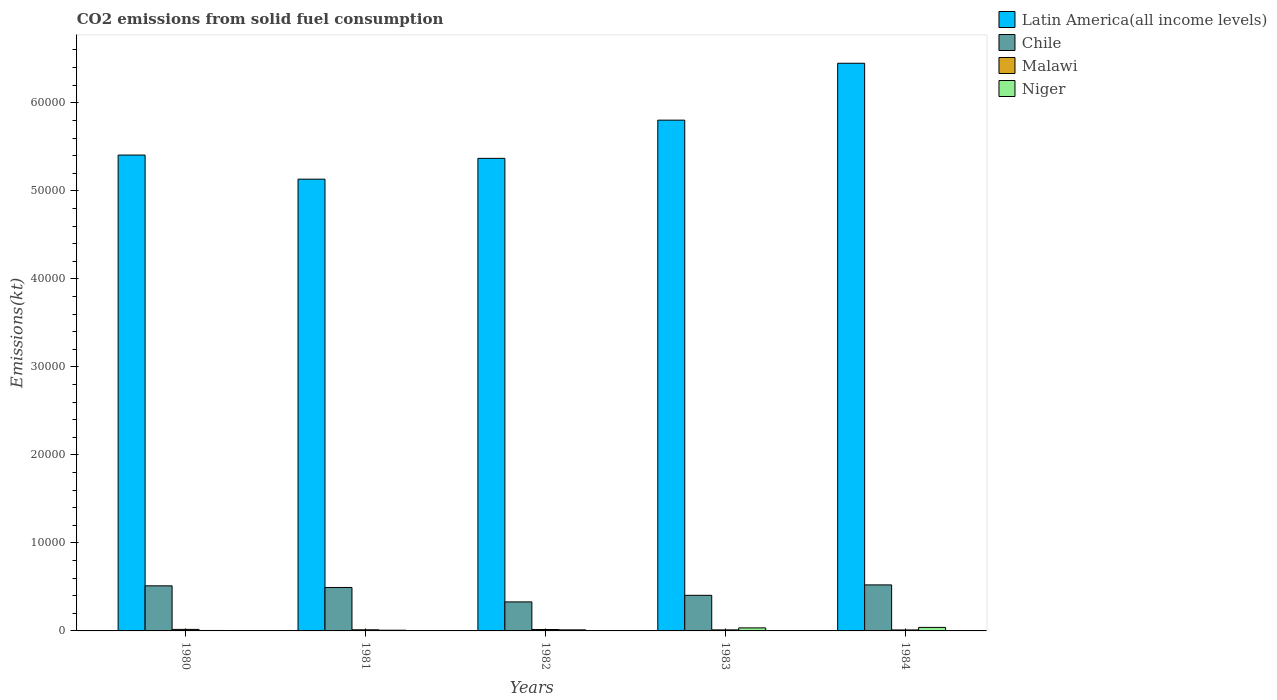Are the number of bars per tick equal to the number of legend labels?
Your answer should be very brief. Yes. Are the number of bars on each tick of the X-axis equal?
Keep it short and to the point. Yes. What is the amount of CO2 emitted in Malawi in 1983?
Your response must be concise. 117.34. Across all years, what is the maximum amount of CO2 emitted in Malawi?
Make the answer very short. 172.35. Across all years, what is the minimum amount of CO2 emitted in Latin America(all income levels)?
Make the answer very short. 5.13e+04. In which year was the amount of CO2 emitted in Malawi maximum?
Ensure brevity in your answer.  1980. In which year was the amount of CO2 emitted in Latin America(all income levels) minimum?
Your answer should be compact. 1981. What is the total amount of CO2 emitted in Latin America(all income levels) in the graph?
Your response must be concise. 2.82e+05. What is the difference between the amount of CO2 emitted in Niger in 1981 and that in 1983?
Your answer should be compact. -264.02. What is the difference between the amount of CO2 emitted in Malawi in 1980 and the amount of CO2 emitted in Latin America(all income levels) in 1984?
Ensure brevity in your answer.  -6.43e+04. What is the average amount of CO2 emitted in Malawi per year?
Keep it short and to the point. 137.88. In the year 1984, what is the difference between the amount of CO2 emitted in Latin America(all income levels) and amount of CO2 emitted in Niger?
Provide a short and direct response. 6.41e+04. What is the ratio of the amount of CO2 emitted in Chile in 1982 to that in 1983?
Keep it short and to the point. 0.82. Is the amount of CO2 emitted in Latin America(all income levels) in 1980 less than that in 1982?
Provide a succinct answer. No. Is the difference between the amount of CO2 emitted in Latin America(all income levels) in 1980 and 1983 greater than the difference between the amount of CO2 emitted in Niger in 1980 and 1983?
Offer a very short reply. No. What is the difference between the highest and the second highest amount of CO2 emitted in Latin America(all income levels)?
Make the answer very short. 6463.64. What is the difference between the highest and the lowest amount of CO2 emitted in Latin America(all income levels)?
Offer a very short reply. 1.32e+04. In how many years, is the amount of CO2 emitted in Malawi greater than the average amount of CO2 emitted in Malawi taken over all years?
Offer a very short reply. 2. What does the 4th bar from the left in 1982 represents?
Offer a terse response. Niger. What does the 2nd bar from the right in 1981 represents?
Offer a terse response. Malawi. Does the graph contain any zero values?
Give a very brief answer. No. Does the graph contain grids?
Provide a short and direct response. No. How many legend labels are there?
Your answer should be very brief. 4. What is the title of the graph?
Offer a very short reply. CO2 emissions from solid fuel consumption. What is the label or title of the Y-axis?
Your response must be concise. Emissions(kt). What is the Emissions(kt) of Latin America(all income levels) in 1980?
Provide a succinct answer. 5.41e+04. What is the Emissions(kt) in Chile in 1980?
Offer a terse response. 5122.8. What is the Emissions(kt) in Malawi in 1980?
Ensure brevity in your answer.  172.35. What is the Emissions(kt) of Niger in 1980?
Your answer should be compact. 51.34. What is the Emissions(kt) of Latin America(all income levels) in 1981?
Make the answer very short. 5.13e+04. What is the Emissions(kt) of Chile in 1981?
Offer a terse response. 4935.78. What is the Emissions(kt) in Malawi in 1981?
Give a very brief answer. 128.34. What is the Emissions(kt) in Niger in 1981?
Your answer should be very brief. 80.67. What is the Emissions(kt) in Latin America(all income levels) in 1982?
Offer a terse response. 5.37e+04. What is the Emissions(kt) in Chile in 1982?
Offer a very short reply. 3296.63. What is the Emissions(kt) in Malawi in 1982?
Provide a short and direct response. 161.35. What is the Emissions(kt) in Niger in 1982?
Make the answer very short. 121.01. What is the Emissions(kt) in Latin America(all income levels) in 1983?
Keep it short and to the point. 5.80e+04. What is the Emissions(kt) in Chile in 1983?
Your answer should be compact. 4044.7. What is the Emissions(kt) in Malawi in 1983?
Offer a terse response. 117.34. What is the Emissions(kt) in Niger in 1983?
Make the answer very short. 344.7. What is the Emissions(kt) in Latin America(all income levels) in 1984?
Ensure brevity in your answer.  6.45e+04. What is the Emissions(kt) in Chile in 1984?
Your answer should be very brief. 5229.14. What is the Emissions(kt) of Malawi in 1984?
Give a very brief answer. 110.01. What is the Emissions(kt) of Niger in 1984?
Provide a short and direct response. 399.7. Across all years, what is the maximum Emissions(kt) in Latin America(all income levels)?
Your answer should be compact. 6.45e+04. Across all years, what is the maximum Emissions(kt) in Chile?
Your answer should be very brief. 5229.14. Across all years, what is the maximum Emissions(kt) in Malawi?
Your answer should be very brief. 172.35. Across all years, what is the maximum Emissions(kt) of Niger?
Give a very brief answer. 399.7. Across all years, what is the minimum Emissions(kt) in Latin America(all income levels)?
Provide a short and direct response. 5.13e+04. Across all years, what is the minimum Emissions(kt) in Chile?
Offer a terse response. 3296.63. Across all years, what is the minimum Emissions(kt) of Malawi?
Offer a very short reply. 110.01. Across all years, what is the minimum Emissions(kt) in Niger?
Ensure brevity in your answer.  51.34. What is the total Emissions(kt) of Latin America(all income levels) in the graph?
Provide a short and direct response. 2.82e+05. What is the total Emissions(kt) in Chile in the graph?
Provide a short and direct response. 2.26e+04. What is the total Emissions(kt) in Malawi in the graph?
Offer a terse response. 689.4. What is the total Emissions(kt) of Niger in the graph?
Provide a succinct answer. 997.42. What is the difference between the Emissions(kt) of Latin America(all income levels) in 1980 and that in 1981?
Offer a very short reply. 2740.02. What is the difference between the Emissions(kt) in Chile in 1980 and that in 1981?
Keep it short and to the point. 187.02. What is the difference between the Emissions(kt) in Malawi in 1980 and that in 1981?
Provide a short and direct response. 44. What is the difference between the Emissions(kt) of Niger in 1980 and that in 1981?
Your response must be concise. -29.34. What is the difference between the Emissions(kt) in Latin America(all income levels) in 1980 and that in 1982?
Your answer should be very brief. 375.46. What is the difference between the Emissions(kt) in Chile in 1980 and that in 1982?
Ensure brevity in your answer.  1826.17. What is the difference between the Emissions(kt) of Malawi in 1980 and that in 1982?
Give a very brief answer. 11. What is the difference between the Emissions(kt) of Niger in 1980 and that in 1982?
Provide a succinct answer. -69.67. What is the difference between the Emissions(kt) of Latin America(all income levels) in 1980 and that in 1983?
Give a very brief answer. -3964.62. What is the difference between the Emissions(kt) in Chile in 1980 and that in 1983?
Keep it short and to the point. 1078.1. What is the difference between the Emissions(kt) of Malawi in 1980 and that in 1983?
Provide a short and direct response. 55.01. What is the difference between the Emissions(kt) of Niger in 1980 and that in 1983?
Your answer should be very brief. -293.36. What is the difference between the Emissions(kt) in Latin America(all income levels) in 1980 and that in 1984?
Keep it short and to the point. -1.04e+04. What is the difference between the Emissions(kt) in Chile in 1980 and that in 1984?
Keep it short and to the point. -106.34. What is the difference between the Emissions(kt) of Malawi in 1980 and that in 1984?
Your answer should be very brief. 62.34. What is the difference between the Emissions(kt) in Niger in 1980 and that in 1984?
Make the answer very short. -348.37. What is the difference between the Emissions(kt) in Latin America(all income levels) in 1981 and that in 1982?
Your answer should be very brief. -2364.56. What is the difference between the Emissions(kt) of Chile in 1981 and that in 1982?
Offer a terse response. 1639.15. What is the difference between the Emissions(kt) of Malawi in 1981 and that in 1982?
Ensure brevity in your answer.  -33. What is the difference between the Emissions(kt) in Niger in 1981 and that in 1982?
Your answer should be compact. -40.34. What is the difference between the Emissions(kt) in Latin America(all income levels) in 1981 and that in 1983?
Keep it short and to the point. -6704.64. What is the difference between the Emissions(kt) in Chile in 1981 and that in 1983?
Offer a terse response. 891.08. What is the difference between the Emissions(kt) of Malawi in 1981 and that in 1983?
Make the answer very short. 11. What is the difference between the Emissions(kt) of Niger in 1981 and that in 1983?
Your response must be concise. -264.02. What is the difference between the Emissions(kt) in Latin America(all income levels) in 1981 and that in 1984?
Provide a short and direct response. -1.32e+04. What is the difference between the Emissions(kt) in Chile in 1981 and that in 1984?
Provide a short and direct response. -293.36. What is the difference between the Emissions(kt) of Malawi in 1981 and that in 1984?
Provide a succinct answer. 18.34. What is the difference between the Emissions(kt) of Niger in 1981 and that in 1984?
Offer a terse response. -319.03. What is the difference between the Emissions(kt) of Latin America(all income levels) in 1982 and that in 1983?
Your answer should be compact. -4340.08. What is the difference between the Emissions(kt) of Chile in 1982 and that in 1983?
Provide a succinct answer. -748.07. What is the difference between the Emissions(kt) in Malawi in 1982 and that in 1983?
Give a very brief answer. 44. What is the difference between the Emissions(kt) in Niger in 1982 and that in 1983?
Your answer should be very brief. -223.69. What is the difference between the Emissions(kt) in Latin America(all income levels) in 1982 and that in 1984?
Provide a short and direct response. -1.08e+04. What is the difference between the Emissions(kt) in Chile in 1982 and that in 1984?
Keep it short and to the point. -1932.51. What is the difference between the Emissions(kt) in Malawi in 1982 and that in 1984?
Give a very brief answer. 51.34. What is the difference between the Emissions(kt) in Niger in 1982 and that in 1984?
Offer a very short reply. -278.69. What is the difference between the Emissions(kt) of Latin America(all income levels) in 1983 and that in 1984?
Provide a succinct answer. -6463.64. What is the difference between the Emissions(kt) of Chile in 1983 and that in 1984?
Offer a terse response. -1184.44. What is the difference between the Emissions(kt) in Malawi in 1983 and that in 1984?
Keep it short and to the point. 7.33. What is the difference between the Emissions(kt) of Niger in 1983 and that in 1984?
Offer a very short reply. -55.01. What is the difference between the Emissions(kt) in Latin America(all income levels) in 1980 and the Emissions(kt) in Chile in 1981?
Your answer should be very brief. 4.91e+04. What is the difference between the Emissions(kt) of Latin America(all income levels) in 1980 and the Emissions(kt) of Malawi in 1981?
Offer a very short reply. 5.39e+04. What is the difference between the Emissions(kt) in Latin America(all income levels) in 1980 and the Emissions(kt) in Niger in 1981?
Your response must be concise. 5.40e+04. What is the difference between the Emissions(kt) of Chile in 1980 and the Emissions(kt) of Malawi in 1981?
Your response must be concise. 4994.45. What is the difference between the Emissions(kt) in Chile in 1980 and the Emissions(kt) in Niger in 1981?
Keep it short and to the point. 5042.12. What is the difference between the Emissions(kt) of Malawi in 1980 and the Emissions(kt) of Niger in 1981?
Give a very brief answer. 91.67. What is the difference between the Emissions(kt) of Latin America(all income levels) in 1980 and the Emissions(kt) of Chile in 1982?
Your answer should be compact. 5.08e+04. What is the difference between the Emissions(kt) in Latin America(all income levels) in 1980 and the Emissions(kt) in Malawi in 1982?
Ensure brevity in your answer.  5.39e+04. What is the difference between the Emissions(kt) in Latin America(all income levels) in 1980 and the Emissions(kt) in Niger in 1982?
Keep it short and to the point. 5.39e+04. What is the difference between the Emissions(kt) in Chile in 1980 and the Emissions(kt) in Malawi in 1982?
Keep it short and to the point. 4961.45. What is the difference between the Emissions(kt) of Chile in 1980 and the Emissions(kt) of Niger in 1982?
Provide a short and direct response. 5001.79. What is the difference between the Emissions(kt) of Malawi in 1980 and the Emissions(kt) of Niger in 1982?
Your response must be concise. 51.34. What is the difference between the Emissions(kt) in Latin America(all income levels) in 1980 and the Emissions(kt) in Chile in 1983?
Provide a succinct answer. 5.00e+04. What is the difference between the Emissions(kt) in Latin America(all income levels) in 1980 and the Emissions(kt) in Malawi in 1983?
Your answer should be compact. 5.39e+04. What is the difference between the Emissions(kt) of Latin America(all income levels) in 1980 and the Emissions(kt) of Niger in 1983?
Your answer should be compact. 5.37e+04. What is the difference between the Emissions(kt) in Chile in 1980 and the Emissions(kt) in Malawi in 1983?
Your answer should be compact. 5005.45. What is the difference between the Emissions(kt) in Chile in 1980 and the Emissions(kt) in Niger in 1983?
Your answer should be compact. 4778.1. What is the difference between the Emissions(kt) in Malawi in 1980 and the Emissions(kt) in Niger in 1983?
Ensure brevity in your answer.  -172.35. What is the difference between the Emissions(kt) in Latin America(all income levels) in 1980 and the Emissions(kt) in Chile in 1984?
Offer a very short reply. 4.88e+04. What is the difference between the Emissions(kt) in Latin America(all income levels) in 1980 and the Emissions(kt) in Malawi in 1984?
Provide a short and direct response. 5.40e+04. What is the difference between the Emissions(kt) in Latin America(all income levels) in 1980 and the Emissions(kt) in Niger in 1984?
Your answer should be very brief. 5.37e+04. What is the difference between the Emissions(kt) of Chile in 1980 and the Emissions(kt) of Malawi in 1984?
Make the answer very short. 5012.79. What is the difference between the Emissions(kt) in Chile in 1980 and the Emissions(kt) in Niger in 1984?
Provide a short and direct response. 4723.1. What is the difference between the Emissions(kt) of Malawi in 1980 and the Emissions(kt) of Niger in 1984?
Offer a very short reply. -227.35. What is the difference between the Emissions(kt) in Latin America(all income levels) in 1981 and the Emissions(kt) in Chile in 1982?
Keep it short and to the point. 4.80e+04. What is the difference between the Emissions(kt) of Latin America(all income levels) in 1981 and the Emissions(kt) of Malawi in 1982?
Your answer should be very brief. 5.12e+04. What is the difference between the Emissions(kt) in Latin America(all income levels) in 1981 and the Emissions(kt) in Niger in 1982?
Provide a succinct answer. 5.12e+04. What is the difference between the Emissions(kt) of Chile in 1981 and the Emissions(kt) of Malawi in 1982?
Offer a very short reply. 4774.43. What is the difference between the Emissions(kt) of Chile in 1981 and the Emissions(kt) of Niger in 1982?
Your answer should be very brief. 4814.77. What is the difference between the Emissions(kt) in Malawi in 1981 and the Emissions(kt) in Niger in 1982?
Make the answer very short. 7.33. What is the difference between the Emissions(kt) in Latin America(all income levels) in 1981 and the Emissions(kt) in Chile in 1983?
Provide a succinct answer. 4.73e+04. What is the difference between the Emissions(kt) of Latin America(all income levels) in 1981 and the Emissions(kt) of Malawi in 1983?
Offer a terse response. 5.12e+04. What is the difference between the Emissions(kt) of Latin America(all income levels) in 1981 and the Emissions(kt) of Niger in 1983?
Offer a terse response. 5.10e+04. What is the difference between the Emissions(kt) in Chile in 1981 and the Emissions(kt) in Malawi in 1983?
Keep it short and to the point. 4818.44. What is the difference between the Emissions(kt) in Chile in 1981 and the Emissions(kt) in Niger in 1983?
Your answer should be very brief. 4591.08. What is the difference between the Emissions(kt) of Malawi in 1981 and the Emissions(kt) of Niger in 1983?
Provide a short and direct response. -216.35. What is the difference between the Emissions(kt) in Latin America(all income levels) in 1981 and the Emissions(kt) in Chile in 1984?
Your response must be concise. 4.61e+04. What is the difference between the Emissions(kt) of Latin America(all income levels) in 1981 and the Emissions(kt) of Malawi in 1984?
Offer a terse response. 5.12e+04. What is the difference between the Emissions(kt) in Latin America(all income levels) in 1981 and the Emissions(kt) in Niger in 1984?
Offer a terse response. 5.09e+04. What is the difference between the Emissions(kt) in Chile in 1981 and the Emissions(kt) in Malawi in 1984?
Your answer should be very brief. 4825.77. What is the difference between the Emissions(kt) of Chile in 1981 and the Emissions(kt) of Niger in 1984?
Provide a succinct answer. 4536.08. What is the difference between the Emissions(kt) of Malawi in 1981 and the Emissions(kt) of Niger in 1984?
Provide a succinct answer. -271.36. What is the difference between the Emissions(kt) of Latin America(all income levels) in 1982 and the Emissions(kt) of Chile in 1983?
Provide a short and direct response. 4.96e+04. What is the difference between the Emissions(kt) of Latin America(all income levels) in 1982 and the Emissions(kt) of Malawi in 1983?
Keep it short and to the point. 5.36e+04. What is the difference between the Emissions(kt) in Latin America(all income levels) in 1982 and the Emissions(kt) in Niger in 1983?
Ensure brevity in your answer.  5.33e+04. What is the difference between the Emissions(kt) of Chile in 1982 and the Emissions(kt) of Malawi in 1983?
Your answer should be very brief. 3179.29. What is the difference between the Emissions(kt) in Chile in 1982 and the Emissions(kt) in Niger in 1983?
Keep it short and to the point. 2951.93. What is the difference between the Emissions(kt) in Malawi in 1982 and the Emissions(kt) in Niger in 1983?
Your response must be concise. -183.35. What is the difference between the Emissions(kt) in Latin America(all income levels) in 1982 and the Emissions(kt) in Chile in 1984?
Your answer should be compact. 4.85e+04. What is the difference between the Emissions(kt) of Latin America(all income levels) in 1982 and the Emissions(kt) of Malawi in 1984?
Give a very brief answer. 5.36e+04. What is the difference between the Emissions(kt) in Latin America(all income levels) in 1982 and the Emissions(kt) in Niger in 1984?
Your response must be concise. 5.33e+04. What is the difference between the Emissions(kt) of Chile in 1982 and the Emissions(kt) of Malawi in 1984?
Provide a succinct answer. 3186.62. What is the difference between the Emissions(kt) of Chile in 1982 and the Emissions(kt) of Niger in 1984?
Make the answer very short. 2896.93. What is the difference between the Emissions(kt) in Malawi in 1982 and the Emissions(kt) in Niger in 1984?
Provide a succinct answer. -238.35. What is the difference between the Emissions(kt) in Latin America(all income levels) in 1983 and the Emissions(kt) in Chile in 1984?
Offer a terse response. 5.28e+04. What is the difference between the Emissions(kt) in Latin America(all income levels) in 1983 and the Emissions(kt) in Malawi in 1984?
Your answer should be very brief. 5.79e+04. What is the difference between the Emissions(kt) in Latin America(all income levels) in 1983 and the Emissions(kt) in Niger in 1984?
Give a very brief answer. 5.76e+04. What is the difference between the Emissions(kt) in Chile in 1983 and the Emissions(kt) in Malawi in 1984?
Provide a succinct answer. 3934.69. What is the difference between the Emissions(kt) in Chile in 1983 and the Emissions(kt) in Niger in 1984?
Your answer should be very brief. 3645. What is the difference between the Emissions(kt) in Malawi in 1983 and the Emissions(kt) in Niger in 1984?
Your answer should be compact. -282.36. What is the average Emissions(kt) of Latin America(all income levels) per year?
Ensure brevity in your answer.  5.63e+04. What is the average Emissions(kt) in Chile per year?
Make the answer very short. 4525.81. What is the average Emissions(kt) in Malawi per year?
Give a very brief answer. 137.88. What is the average Emissions(kt) in Niger per year?
Ensure brevity in your answer.  199.48. In the year 1980, what is the difference between the Emissions(kt) of Latin America(all income levels) and Emissions(kt) of Chile?
Ensure brevity in your answer.  4.89e+04. In the year 1980, what is the difference between the Emissions(kt) in Latin America(all income levels) and Emissions(kt) in Malawi?
Give a very brief answer. 5.39e+04. In the year 1980, what is the difference between the Emissions(kt) in Latin America(all income levels) and Emissions(kt) in Niger?
Offer a terse response. 5.40e+04. In the year 1980, what is the difference between the Emissions(kt) of Chile and Emissions(kt) of Malawi?
Offer a terse response. 4950.45. In the year 1980, what is the difference between the Emissions(kt) in Chile and Emissions(kt) in Niger?
Ensure brevity in your answer.  5071.46. In the year 1980, what is the difference between the Emissions(kt) of Malawi and Emissions(kt) of Niger?
Provide a short and direct response. 121.01. In the year 1981, what is the difference between the Emissions(kt) of Latin America(all income levels) and Emissions(kt) of Chile?
Provide a short and direct response. 4.64e+04. In the year 1981, what is the difference between the Emissions(kt) in Latin America(all income levels) and Emissions(kt) in Malawi?
Your answer should be compact. 5.12e+04. In the year 1981, what is the difference between the Emissions(kt) of Latin America(all income levels) and Emissions(kt) of Niger?
Provide a succinct answer. 5.12e+04. In the year 1981, what is the difference between the Emissions(kt) in Chile and Emissions(kt) in Malawi?
Your answer should be compact. 4807.44. In the year 1981, what is the difference between the Emissions(kt) of Chile and Emissions(kt) of Niger?
Your response must be concise. 4855.11. In the year 1981, what is the difference between the Emissions(kt) in Malawi and Emissions(kt) in Niger?
Your answer should be very brief. 47.67. In the year 1982, what is the difference between the Emissions(kt) in Latin America(all income levels) and Emissions(kt) in Chile?
Provide a succinct answer. 5.04e+04. In the year 1982, what is the difference between the Emissions(kt) of Latin America(all income levels) and Emissions(kt) of Malawi?
Ensure brevity in your answer.  5.35e+04. In the year 1982, what is the difference between the Emissions(kt) in Latin America(all income levels) and Emissions(kt) in Niger?
Provide a succinct answer. 5.36e+04. In the year 1982, what is the difference between the Emissions(kt) in Chile and Emissions(kt) in Malawi?
Your answer should be very brief. 3135.28. In the year 1982, what is the difference between the Emissions(kt) of Chile and Emissions(kt) of Niger?
Offer a very short reply. 3175.62. In the year 1982, what is the difference between the Emissions(kt) in Malawi and Emissions(kt) in Niger?
Provide a short and direct response. 40.34. In the year 1983, what is the difference between the Emissions(kt) in Latin America(all income levels) and Emissions(kt) in Chile?
Offer a terse response. 5.40e+04. In the year 1983, what is the difference between the Emissions(kt) of Latin America(all income levels) and Emissions(kt) of Malawi?
Keep it short and to the point. 5.79e+04. In the year 1983, what is the difference between the Emissions(kt) in Latin America(all income levels) and Emissions(kt) in Niger?
Your answer should be compact. 5.77e+04. In the year 1983, what is the difference between the Emissions(kt) in Chile and Emissions(kt) in Malawi?
Provide a succinct answer. 3927.36. In the year 1983, what is the difference between the Emissions(kt) in Chile and Emissions(kt) in Niger?
Ensure brevity in your answer.  3700. In the year 1983, what is the difference between the Emissions(kt) of Malawi and Emissions(kt) of Niger?
Offer a very short reply. -227.35. In the year 1984, what is the difference between the Emissions(kt) of Latin America(all income levels) and Emissions(kt) of Chile?
Offer a very short reply. 5.93e+04. In the year 1984, what is the difference between the Emissions(kt) of Latin America(all income levels) and Emissions(kt) of Malawi?
Your answer should be compact. 6.44e+04. In the year 1984, what is the difference between the Emissions(kt) of Latin America(all income levels) and Emissions(kt) of Niger?
Make the answer very short. 6.41e+04. In the year 1984, what is the difference between the Emissions(kt) of Chile and Emissions(kt) of Malawi?
Give a very brief answer. 5119.13. In the year 1984, what is the difference between the Emissions(kt) of Chile and Emissions(kt) of Niger?
Provide a short and direct response. 4829.44. In the year 1984, what is the difference between the Emissions(kt) of Malawi and Emissions(kt) of Niger?
Ensure brevity in your answer.  -289.69. What is the ratio of the Emissions(kt) in Latin America(all income levels) in 1980 to that in 1981?
Keep it short and to the point. 1.05. What is the ratio of the Emissions(kt) in Chile in 1980 to that in 1981?
Keep it short and to the point. 1.04. What is the ratio of the Emissions(kt) in Malawi in 1980 to that in 1981?
Keep it short and to the point. 1.34. What is the ratio of the Emissions(kt) of Niger in 1980 to that in 1981?
Your answer should be compact. 0.64. What is the ratio of the Emissions(kt) of Chile in 1980 to that in 1982?
Make the answer very short. 1.55. What is the ratio of the Emissions(kt) of Malawi in 1980 to that in 1982?
Provide a short and direct response. 1.07. What is the ratio of the Emissions(kt) of Niger in 1980 to that in 1982?
Provide a succinct answer. 0.42. What is the ratio of the Emissions(kt) in Latin America(all income levels) in 1980 to that in 1983?
Give a very brief answer. 0.93. What is the ratio of the Emissions(kt) of Chile in 1980 to that in 1983?
Make the answer very short. 1.27. What is the ratio of the Emissions(kt) in Malawi in 1980 to that in 1983?
Your answer should be compact. 1.47. What is the ratio of the Emissions(kt) of Niger in 1980 to that in 1983?
Offer a terse response. 0.15. What is the ratio of the Emissions(kt) of Latin America(all income levels) in 1980 to that in 1984?
Ensure brevity in your answer.  0.84. What is the ratio of the Emissions(kt) in Chile in 1980 to that in 1984?
Your response must be concise. 0.98. What is the ratio of the Emissions(kt) of Malawi in 1980 to that in 1984?
Keep it short and to the point. 1.57. What is the ratio of the Emissions(kt) of Niger in 1980 to that in 1984?
Make the answer very short. 0.13. What is the ratio of the Emissions(kt) in Latin America(all income levels) in 1981 to that in 1982?
Your answer should be compact. 0.96. What is the ratio of the Emissions(kt) in Chile in 1981 to that in 1982?
Your answer should be very brief. 1.5. What is the ratio of the Emissions(kt) in Malawi in 1981 to that in 1982?
Offer a terse response. 0.8. What is the ratio of the Emissions(kt) of Niger in 1981 to that in 1982?
Offer a very short reply. 0.67. What is the ratio of the Emissions(kt) in Latin America(all income levels) in 1981 to that in 1983?
Keep it short and to the point. 0.88. What is the ratio of the Emissions(kt) in Chile in 1981 to that in 1983?
Your response must be concise. 1.22. What is the ratio of the Emissions(kt) of Malawi in 1981 to that in 1983?
Give a very brief answer. 1.09. What is the ratio of the Emissions(kt) of Niger in 1981 to that in 1983?
Your response must be concise. 0.23. What is the ratio of the Emissions(kt) in Latin America(all income levels) in 1981 to that in 1984?
Your response must be concise. 0.8. What is the ratio of the Emissions(kt) of Chile in 1981 to that in 1984?
Give a very brief answer. 0.94. What is the ratio of the Emissions(kt) in Niger in 1981 to that in 1984?
Your response must be concise. 0.2. What is the ratio of the Emissions(kt) of Latin America(all income levels) in 1982 to that in 1983?
Provide a short and direct response. 0.93. What is the ratio of the Emissions(kt) of Chile in 1982 to that in 1983?
Your answer should be very brief. 0.81. What is the ratio of the Emissions(kt) in Malawi in 1982 to that in 1983?
Provide a short and direct response. 1.38. What is the ratio of the Emissions(kt) in Niger in 1982 to that in 1983?
Your answer should be compact. 0.35. What is the ratio of the Emissions(kt) in Latin America(all income levels) in 1982 to that in 1984?
Make the answer very short. 0.83. What is the ratio of the Emissions(kt) in Chile in 1982 to that in 1984?
Keep it short and to the point. 0.63. What is the ratio of the Emissions(kt) of Malawi in 1982 to that in 1984?
Make the answer very short. 1.47. What is the ratio of the Emissions(kt) of Niger in 1982 to that in 1984?
Give a very brief answer. 0.3. What is the ratio of the Emissions(kt) in Latin America(all income levels) in 1983 to that in 1984?
Provide a short and direct response. 0.9. What is the ratio of the Emissions(kt) in Chile in 1983 to that in 1984?
Make the answer very short. 0.77. What is the ratio of the Emissions(kt) of Malawi in 1983 to that in 1984?
Your answer should be very brief. 1.07. What is the ratio of the Emissions(kt) of Niger in 1983 to that in 1984?
Offer a terse response. 0.86. What is the difference between the highest and the second highest Emissions(kt) in Latin America(all income levels)?
Make the answer very short. 6463.64. What is the difference between the highest and the second highest Emissions(kt) in Chile?
Give a very brief answer. 106.34. What is the difference between the highest and the second highest Emissions(kt) in Malawi?
Your response must be concise. 11. What is the difference between the highest and the second highest Emissions(kt) in Niger?
Your response must be concise. 55.01. What is the difference between the highest and the lowest Emissions(kt) in Latin America(all income levels)?
Your response must be concise. 1.32e+04. What is the difference between the highest and the lowest Emissions(kt) of Chile?
Your answer should be compact. 1932.51. What is the difference between the highest and the lowest Emissions(kt) of Malawi?
Ensure brevity in your answer.  62.34. What is the difference between the highest and the lowest Emissions(kt) in Niger?
Your response must be concise. 348.37. 